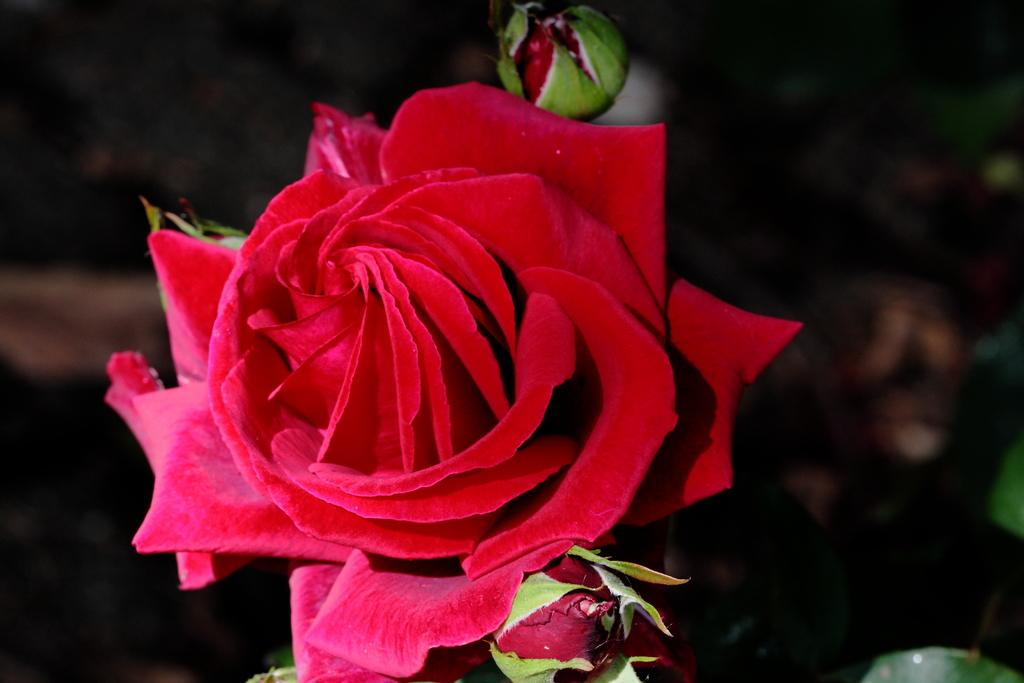What type of flower is in the image? There is a red color rose in the image. Are there any unopened flowers in the image? Yes, there are rose buds in the image. What is the color of the background in the image? The background of the image is dark. How many girls are holding the flowers in the image? There are no girls present in the image; it only features a red color rose and rose buds. 